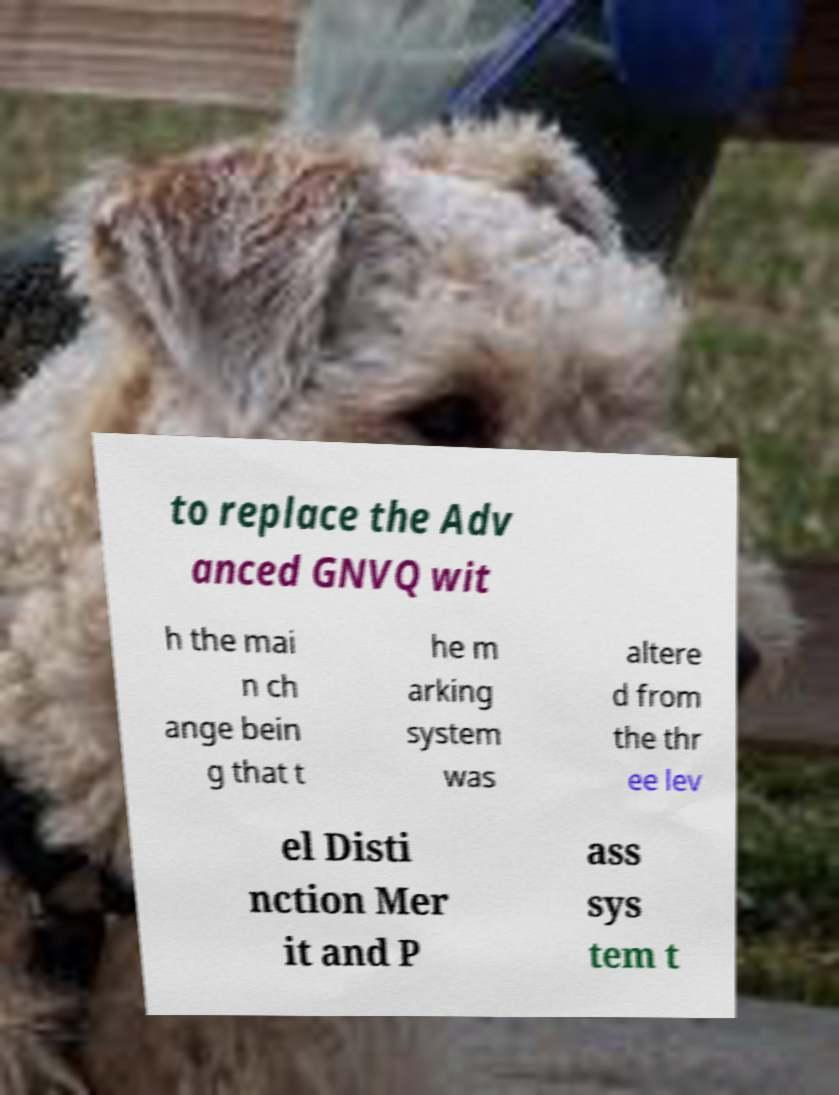Please identify and transcribe the text found in this image. to replace the Adv anced GNVQ wit h the mai n ch ange bein g that t he m arking system was altere d from the thr ee lev el Disti nction Mer it and P ass sys tem t 